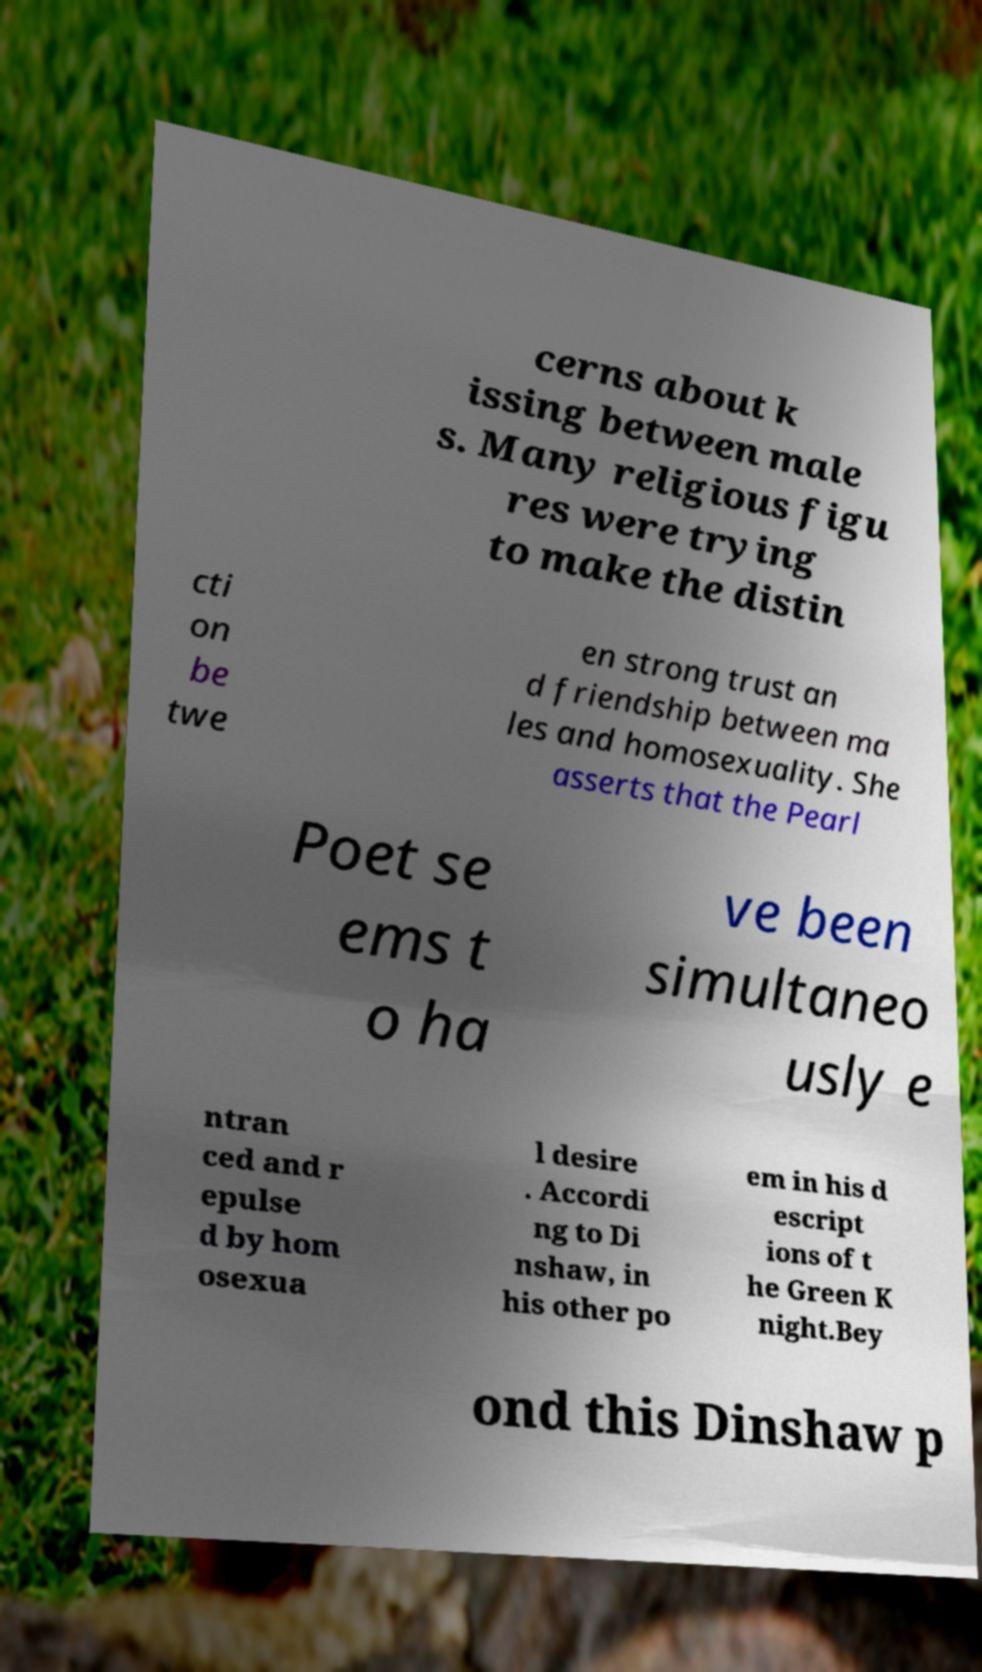Could you assist in decoding the text presented in this image and type it out clearly? cerns about k issing between male s. Many religious figu res were trying to make the distin cti on be twe en strong trust an d friendship between ma les and homosexuality. She asserts that the Pearl Poet se ems t o ha ve been simultaneo usly e ntran ced and r epulse d by hom osexua l desire . Accordi ng to Di nshaw, in his other po em in his d escript ions of t he Green K night.Bey ond this Dinshaw p 